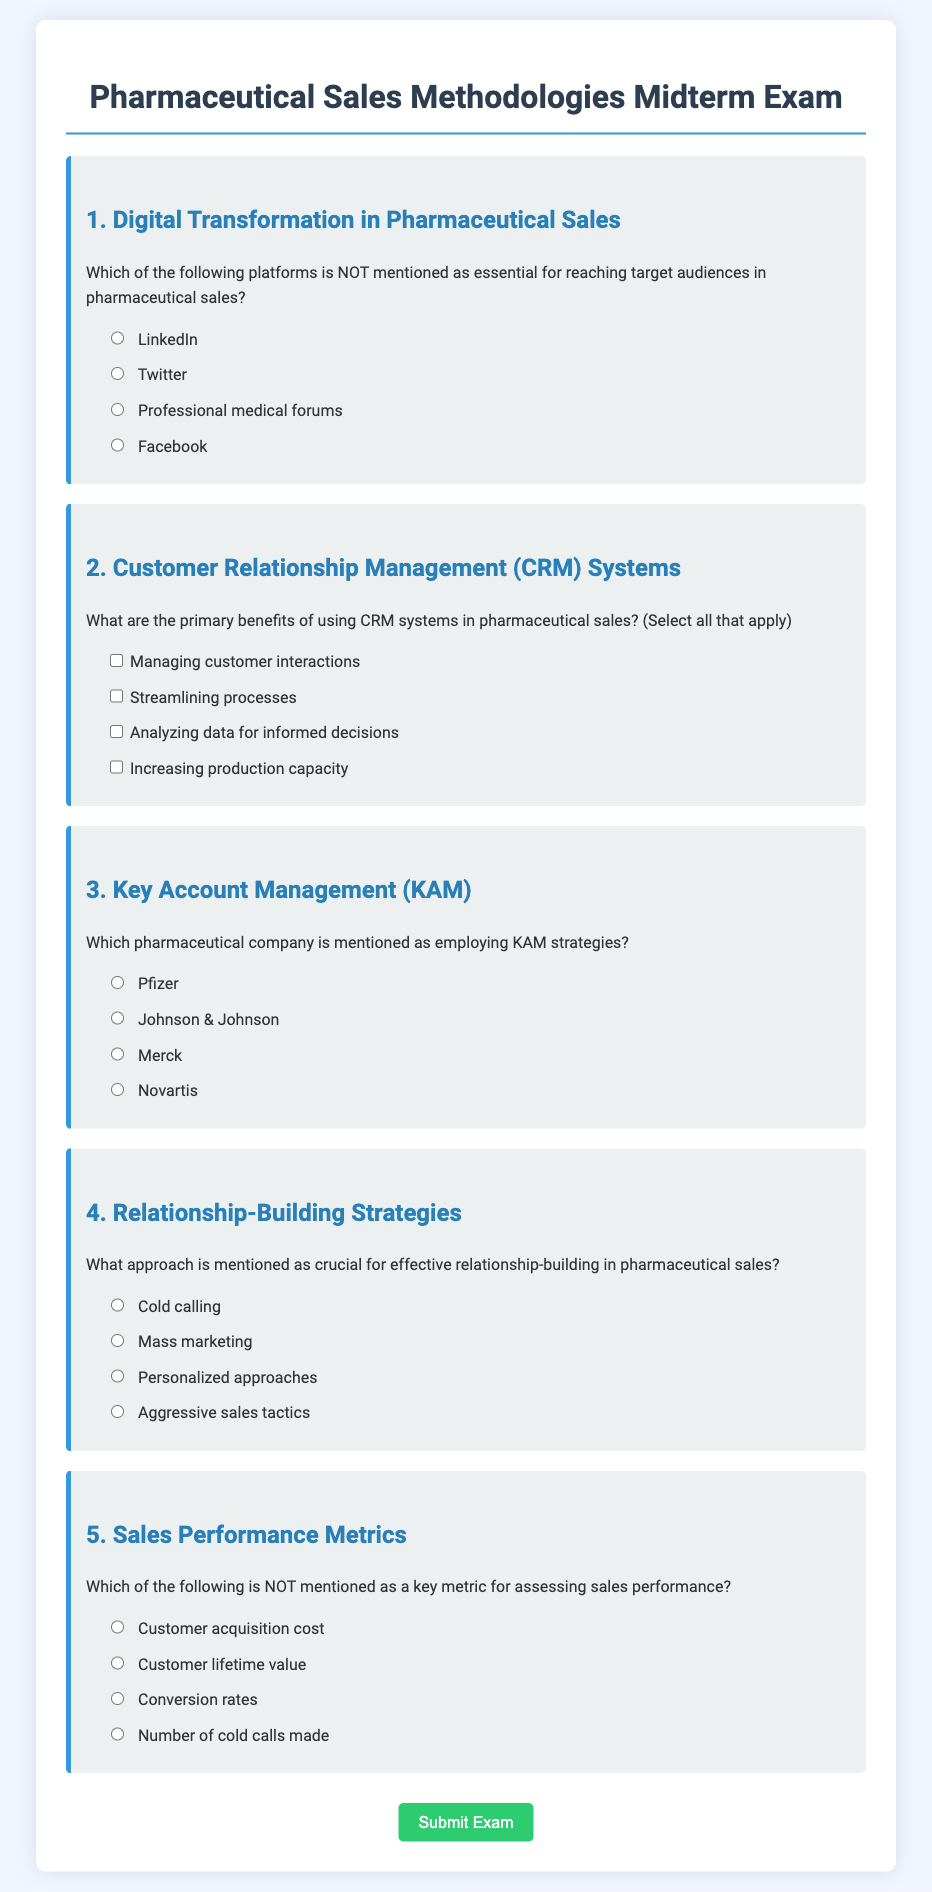What is the title of the document? The title of the document is prominently displayed in the header section, indicating the subject of the midterm exam.
Answer: Pharmaceutical Sales Methodologies Midterm Exam Which question focuses on Digital Transformation? The specific question about Digital Transformation is labeled under the corresponding heading, making it easily identifiable.
Answer: 1. Digital Transformation in Pharmaceutical Sales What type of answers does question 2 require? Question 2 provides options that allow for multiple correct answers, indicating that it's a selection-type question rather than a single-choice question.
Answer: Select all that apply Which company is mentioned in question 3? The companies listed in question 3 can be found as options for the inquiry regarding Key Account Management strategies.
Answer: Pfizer What is the purpose of the submit button? The submit button is intended for submitting the exam, as described in the document's interactive form section.
Answer: Submit Exam What is the color theme of the document? The document utilizes a specific color scheme, prevalent in various elements, including background and text colors.
Answer: Blue and Green Which relationship-building approach is highlighted? The approach necessary for effective relationship-building is explicitly stated in question 4 as part of the document's content.
Answer: Personalized approaches How are the answers presented for the multiple-choice questions? Answers are displayed in a clear, accessible format with radio buttons, helping users select their responses easily.
Answer: Radio buttons What does the alert indicate when the exam is submitted? The alert serves as a confirmation message for user interaction, indicating successful submission of the exam.
Answer: Exam submitted successfully 